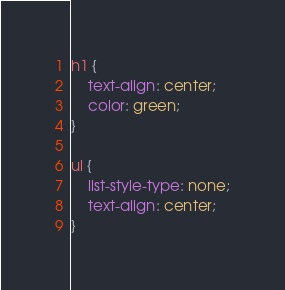Convert code to text. <code><loc_0><loc_0><loc_500><loc_500><_CSS_>h1 {
    text-align: center;
    color: green;
}

ul {
    list-style-type: none;
    text-align: center;
}</code> 